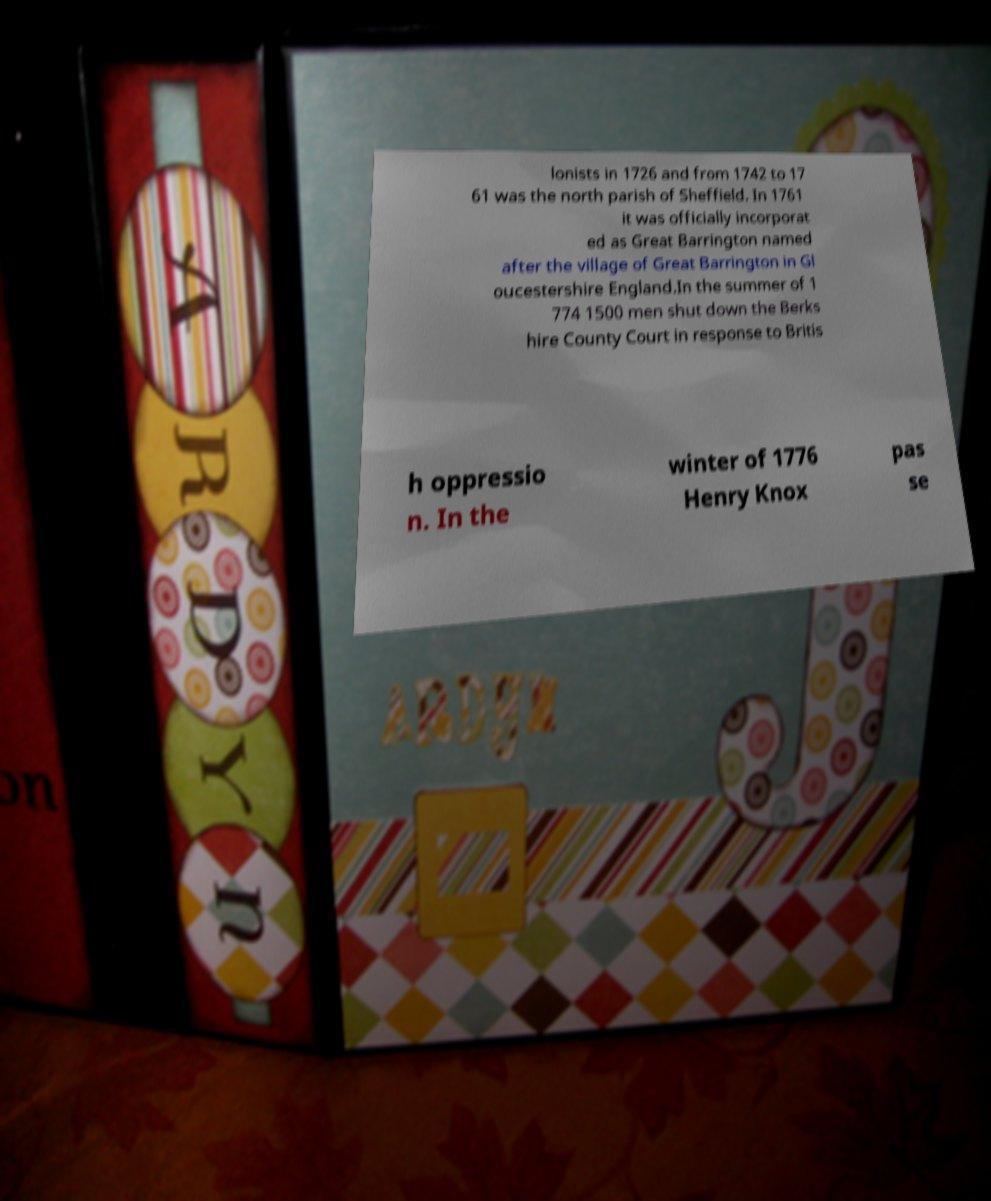For documentation purposes, I need the text within this image transcribed. Could you provide that? lonists in 1726 and from 1742 to 17 61 was the north parish of Sheffield. In 1761 it was officially incorporat ed as Great Barrington named after the village of Great Barrington in Gl oucestershire England.In the summer of 1 774 1500 men shut down the Berks hire County Court in response to Britis h oppressio n. In the winter of 1776 Henry Knox pas se 